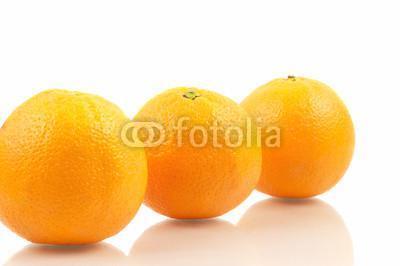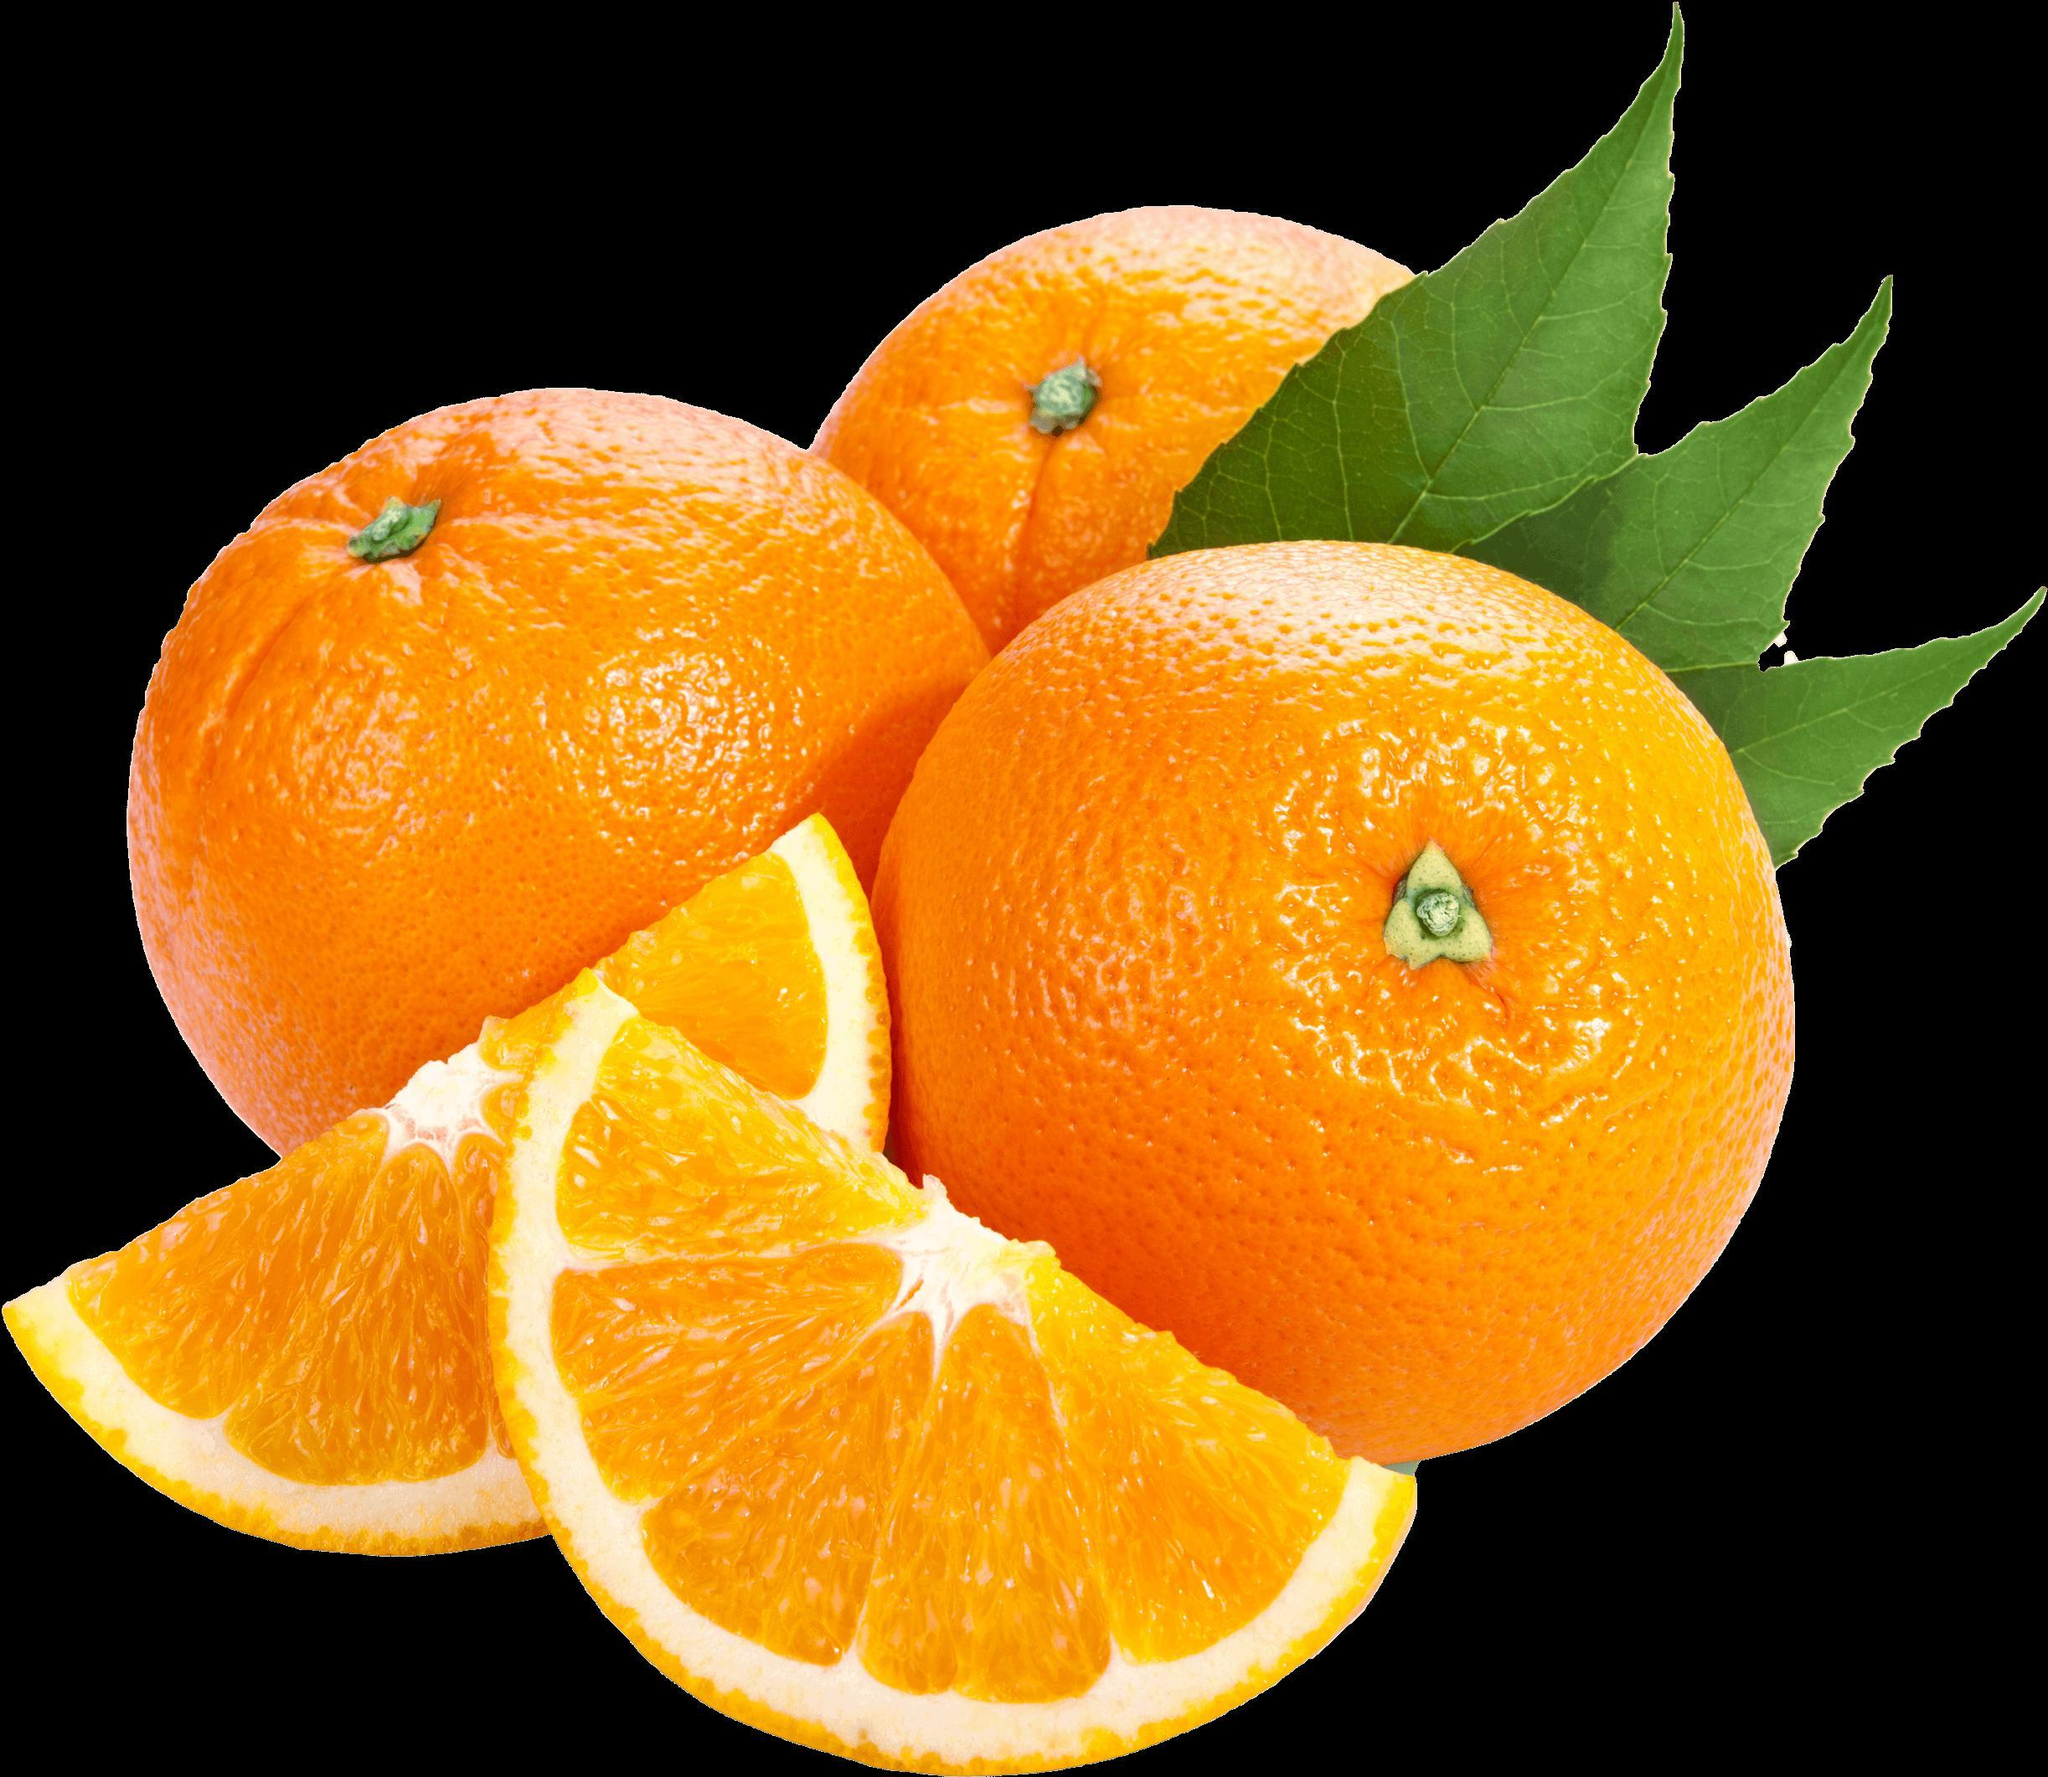The first image is the image on the left, the second image is the image on the right. For the images shown, is this caption "One photo has greenery and one photo has an orange that is cut, and all photos have at least three oranges." true? Answer yes or no. Yes. The first image is the image on the left, the second image is the image on the right. Analyze the images presented: Is the assertion "The right image includes green leaves with three whole oranges, and one image includes two cut orange parts." valid? Answer yes or no. Yes. 